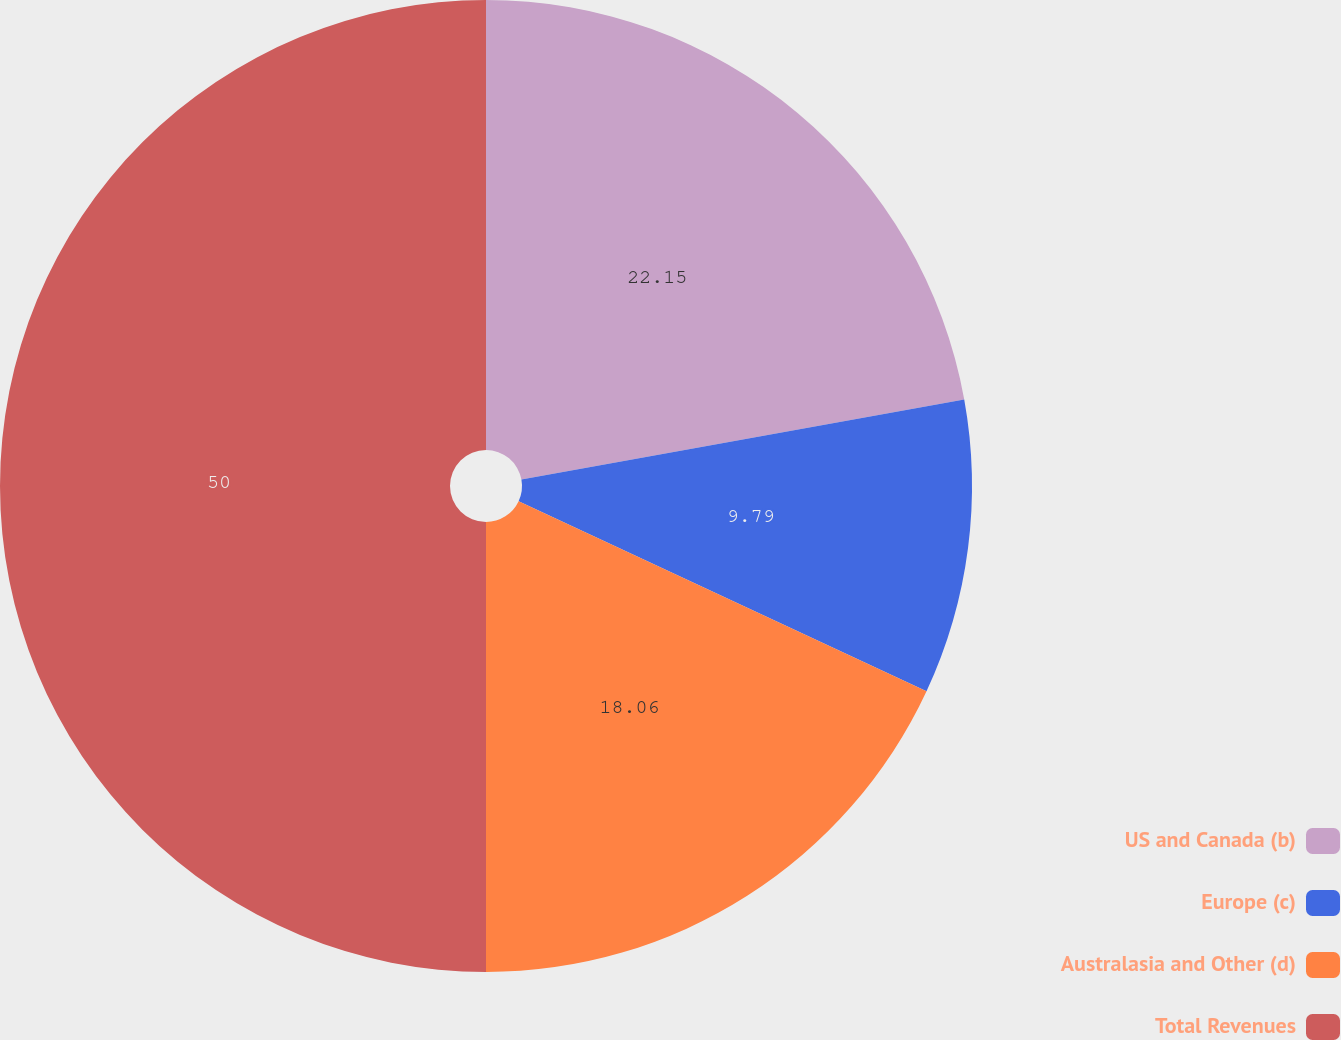Convert chart to OTSL. <chart><loc_0><loc_0><loc_500><loc_500><pie_chart><fcel>US and Canada (b)<fcel>Europe (c)<fcel>Australasia and Other (d)<fcel>Total Revenues<nl><fcel>22.15%<fcel>9.79%<fcel>18.06%<fcel>50.0%<nl></chart> 